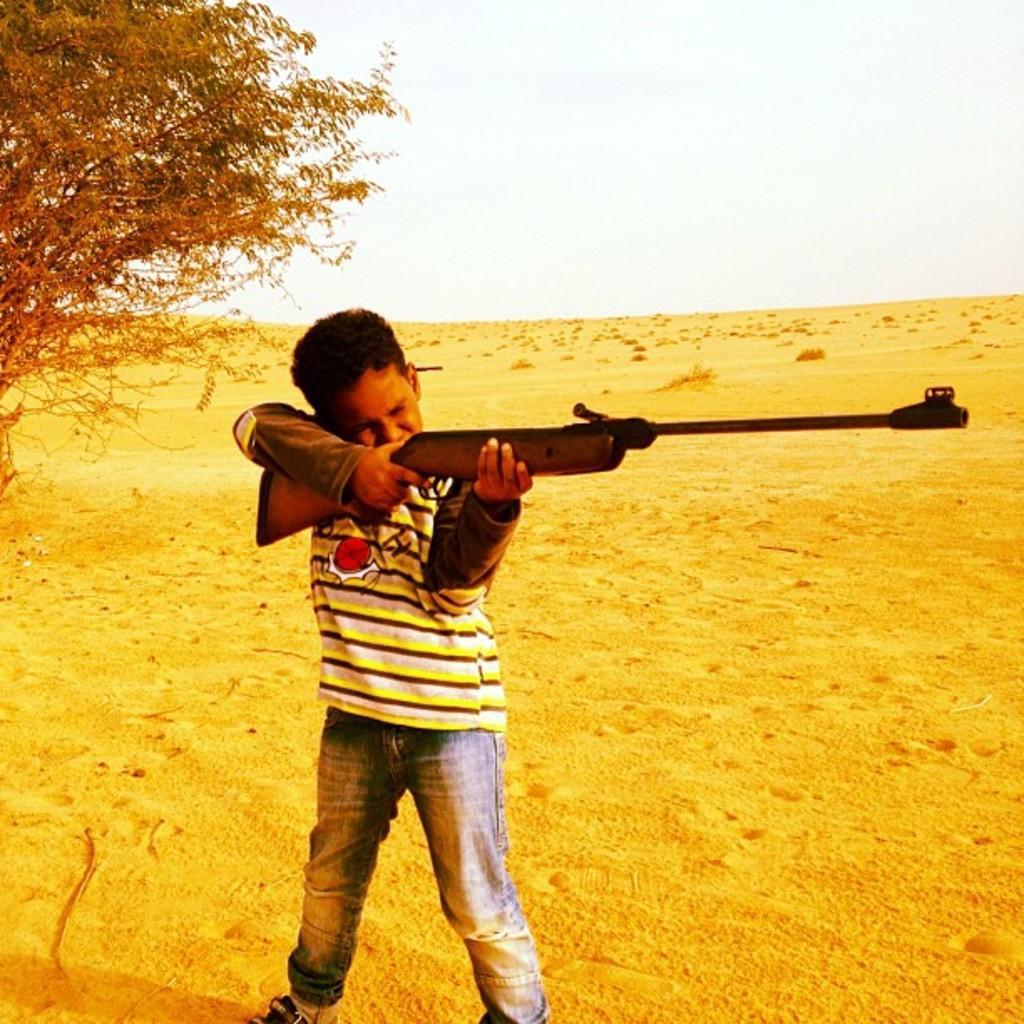In one or two sentences, can you explain what this image depicts? As we can see in the image there is sand, tree, sky and a person holding gun. 